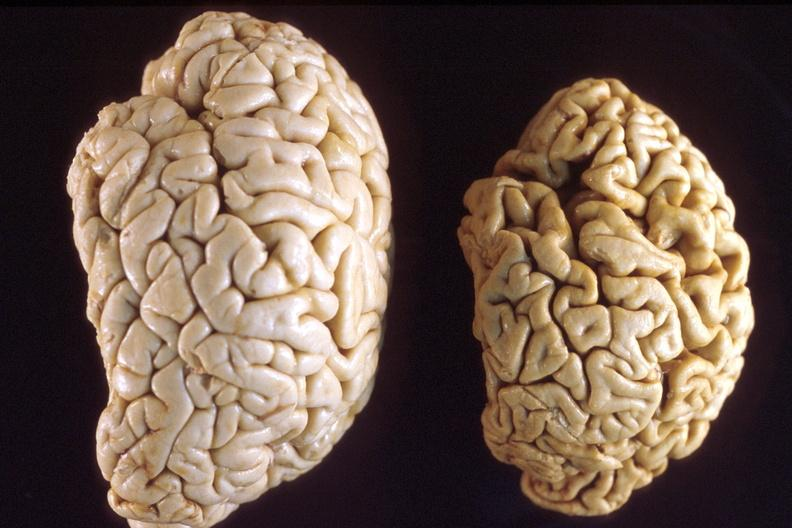does this image show brain, atrophy and normal?
Answer the question using a single word or phrase. Yes 